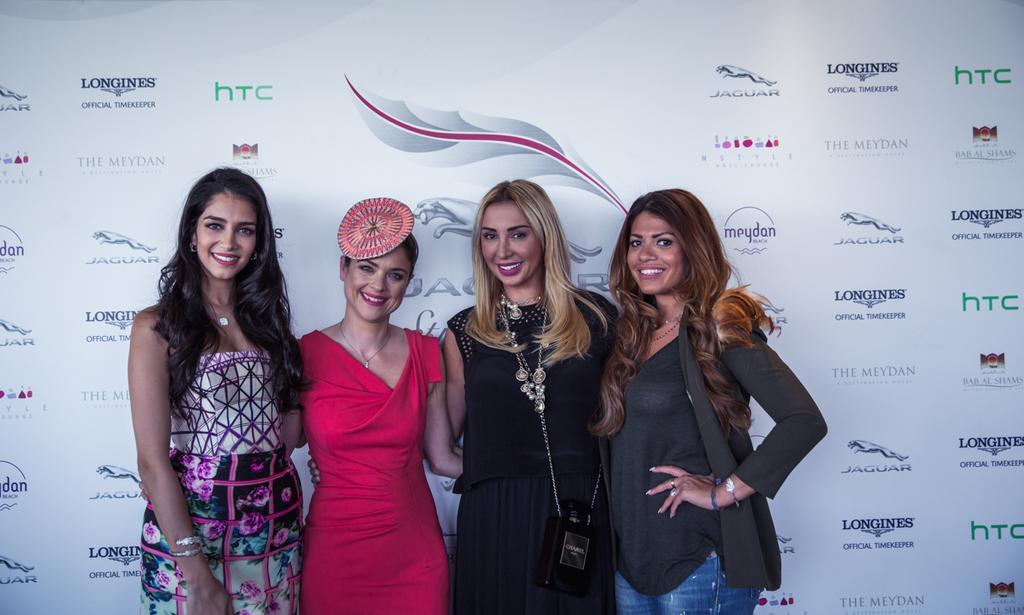How many women are present in the image? There are four women in the image. What are the women doing in the image? The women are standing. What are the women wearing in the image? The women are wearing clothes, neck chains, bracelets, and finger rings. What can be seen in the background of the image? There is a poster visible in the background. What type of cactus can be seen growing near the women in the image? There is no cactus present in the image. What bird is perched on the shoulder of one of the women in the image? There are no birds visible in the image. 